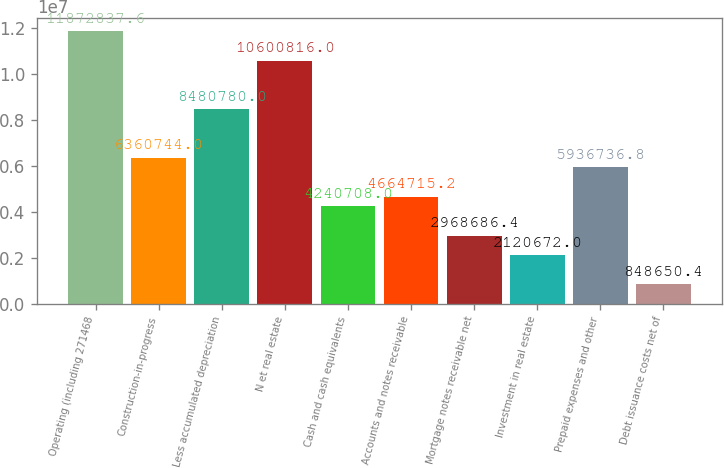Convert chart to OTSL. <chart><loc_0><loc_0><loc_500><loc_500><bar_chart><fcel>Operating (including 271468<fcel>Construction-in-progress<fcel>Less accumulated depreciation<fcel>N et real estate<fcel>Cash and cash equivalents<fcel>Accounts and notes receivable<fcel>Mortgage notes receivable net<fcel>Investment in real estate<fcel>Prepaid expenses and other<fcel>Debt issuance costs net of<nl><fcel>1.18728e+07<fcel>6.36074e+06<fcel>8.48078e+06<fcel>1.06008e+07<fcel>4.24071e+06<fcel>4.66472e+06<fcel>2.96869e+06<fcel>2.12067e+06<fcel>5.93674e+06<fcel>848650<nl></chart> 